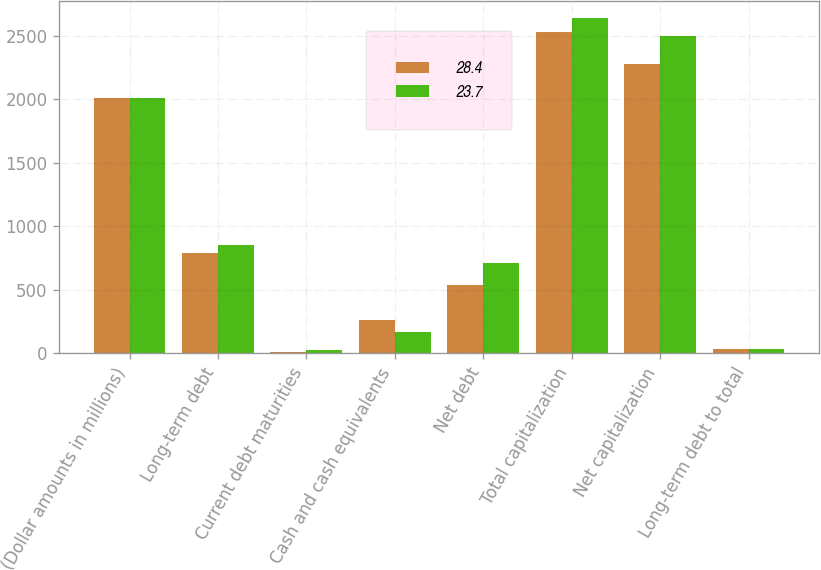<chart> <loc_0><loc_0><loc_500><loc_500><stacked_bar_chart><ecel><fcel>(Dollar amounts in millions)<fcel>Long-term debt<fcel>Current debt maturities<fcel>Cash and cash equivalents<fcel>Net debt<fcel>Total capitalization<fcel>Net capitalization<fcel>Long-term debt to total<nl><fcel>28.4<fcel>2009<fcel>789<fcel>10<fcel>260<fcel>539<fcel>2526<fcel>2276<fcel>31.2<nl><fcel>23.7<fcel>2008<fcel>851<fcel>22<fcel>165<fcel>708<fcel>2638<fcel>2495<fcel>32.2<nl></chart> 